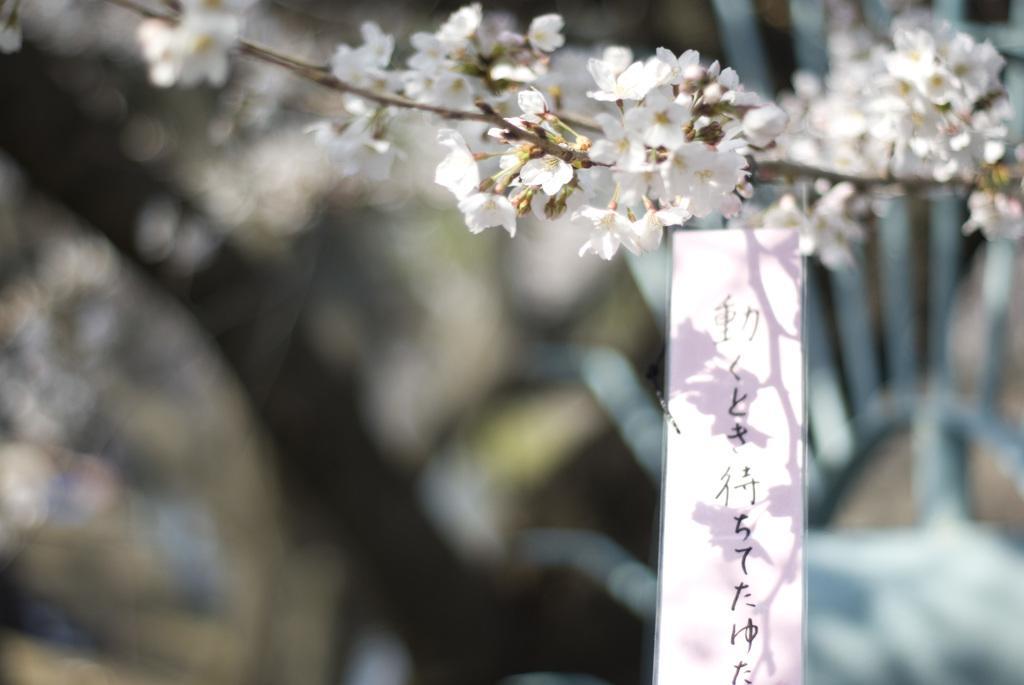How would you summarize this image in a sentence or two? In this picture there are flowers at the top side of the image and there is a label on the right side of the image. 